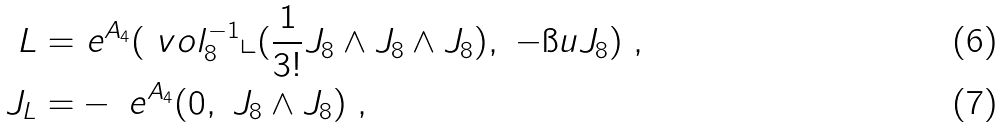Convert formula to latex. <formula><loc_0><loc_0><loc_500><loc_500>L = & \ e ^ { A _ { 4 } } ( \ v o l ^ { - 1 } _ { 8 } \llcorner ( \frac { 1 } { 3 ! } J _ { 8 } \wedge J _ { 8 } \wedge J _ { 8 } ) , \ - \i u J _ { 8 } ) \ , \\ J _ { L } = & - \ e ^ { A _ { 4 } } ( 0 , \ J _ { 8 } \wedge J _ { 8 } ) \ ,</formula> 